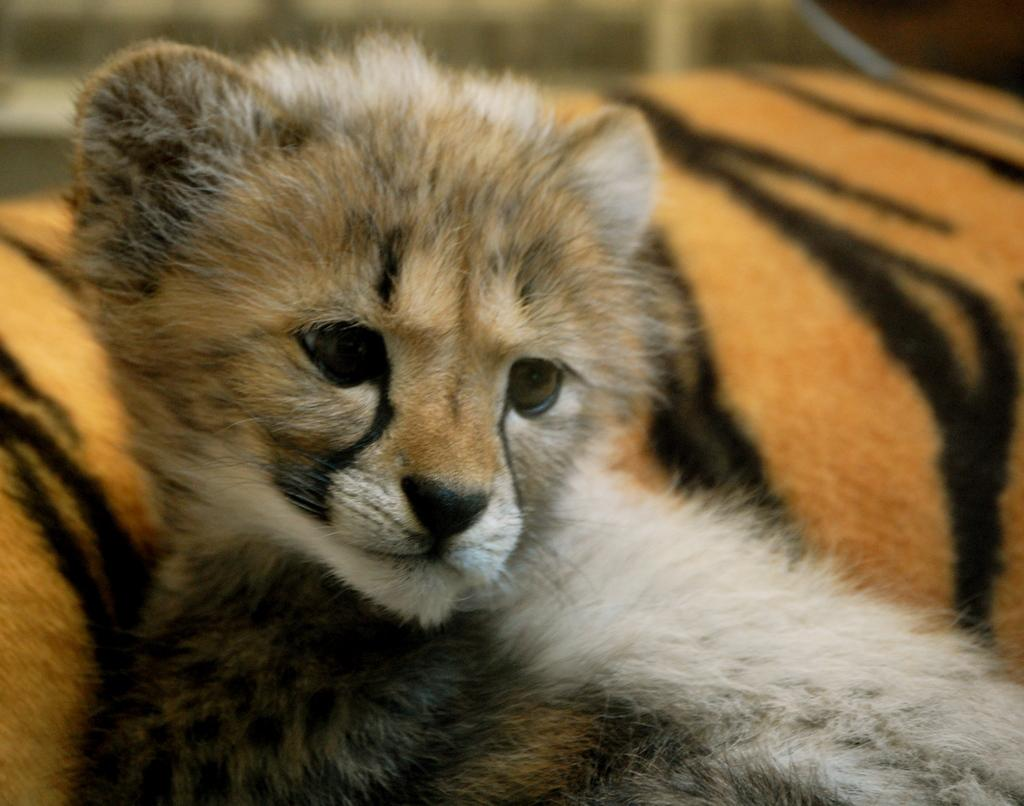What types of living organisms can be seen in the image? There are animals in the image. Can you describe the background of the image? The background of the image is blurred. In which direction is the stream flowing in the image? There is no stream present in the image. How many steps are visible in the image? There are no steps visible in the image. 